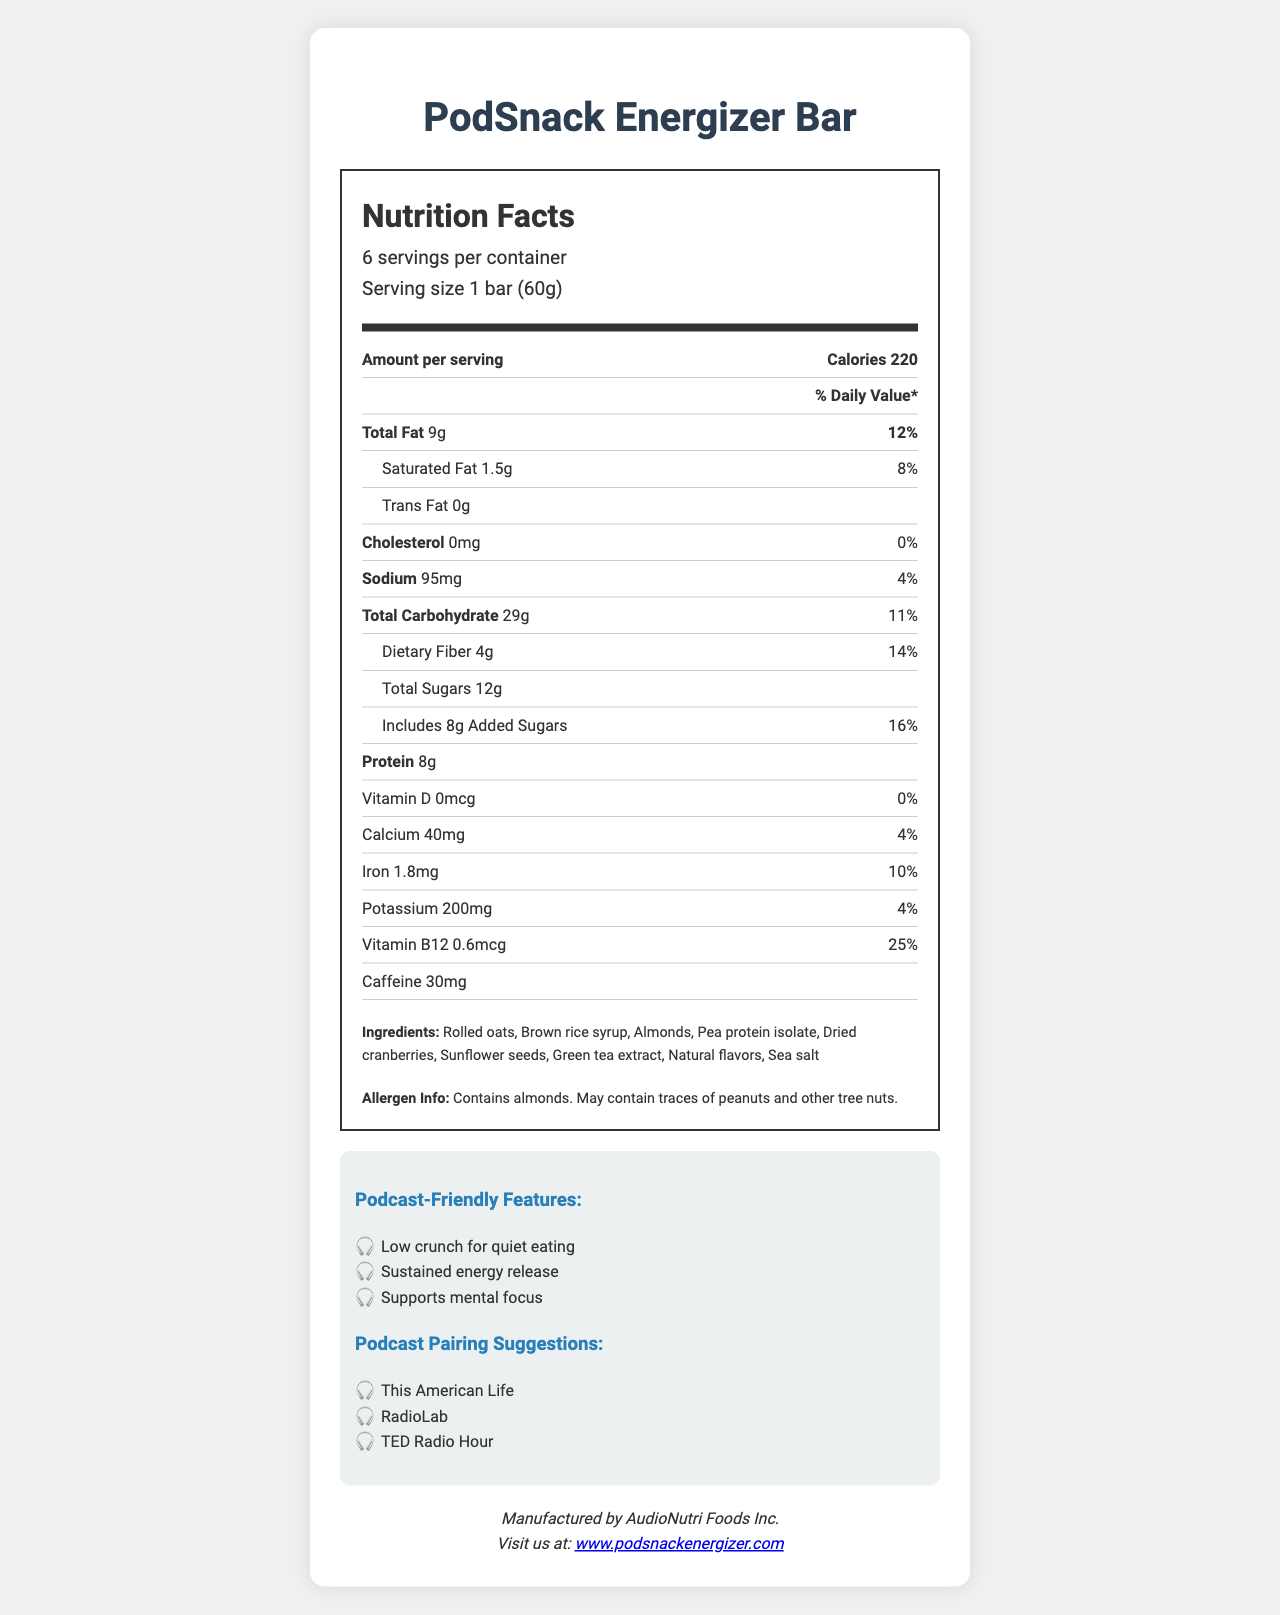Who is the manufacturer of the PodSnack Energizer Bar? The manufacturer information is listed at the bottom of the document under the heading "manufacturer info".
Answer: AudioNutri Foods Inc. How many calories are in one serving of the PodSnack Energizer Bar? The calorie content per serving is indicated in the "Amount per serving" section.
Answer: 220 calories What is the main source of protein in the PodSnack Energizer Bar? The ingredients list includes "Pea protein isolate," which is a common source of protein.
Answer: Pea protein isolate How much total fat does one bar of the PodSnack Energizer Bar contain? The total fat content per serving is provided in the nutrient row labeled "Total Fat".
Answer: 9g What percentage of the daily value for dietary fiber does one bar of the PodSnack Energizer Bar provide? The daily value percentage for dietary fiber is shown in the sub-nutrient row labeled "Dietary Fiber".
Answer: 14% Which of the following podcast-friendly features is NOT listed for the PodSnack Energizer Bar?
A. Low crunch for quiet eating
B. High sugar content
C. Sustained energy release
D. Supports mental focus The document lists "Low crunch for quiet eating", "Sustained energy release", and "Supports mental focus" as podcast-friendly features, but does not mention "High sugar content".
Answer: B. High sugar content How many servings are there in one container of the PodSnack Energizer Bar? The serving information at the top specifies "6 servings per container".
Answer: 6 servings Which nutrient in the PodSnack Energizer Bar contributes 0% of the daily value? A. Vitamin D B. Iron C. Potassium D. Protein The daily value percentage of Vitamin D is 0% as shown in the nutrient row for Vitamin D.
Answer: A. Vitamin D Does the PodSnack Energizer Bar contain any cholesterol? The cholesterol content is listed as "0mg," and the daily value is 0%.
Answer: No What is the main purpose of the document? The document includes nutritional values per serving, serving size, percentage of daily values, ingredients, allergens, manufacturer information, and suggestions for podcast pairings, with a focus on being suitable for long podcast listening sessions.
Answer: The document is a Nutrition Facts Label for the PodSnack Energizer Bar and provides detailed nutritional information, ingredient list, allergen information, and podcast-friendly features. What is the total caffeine content in one serving of the PodSnack Energizer Bar? The caffeine content is specified in the nutrient row for caffeine.
Answer: 30mg Can you find out if the PodSnack Energizer Bar is gluten-free based on the document? The document does not provide specific information on whether the product is gluten-free.
Answer: Not enough information Which of the listed podcasts is a suggested pairing for the PodSnack Energizer Bar? A. This American Life B. 99% Invisible C. Freakonomics Radio The suggested podcasts are "This American Life", "RadioLab", and "TED Radio Hour", as listed in the podcast pairing suggestions section.
Answer: A. This American Life 